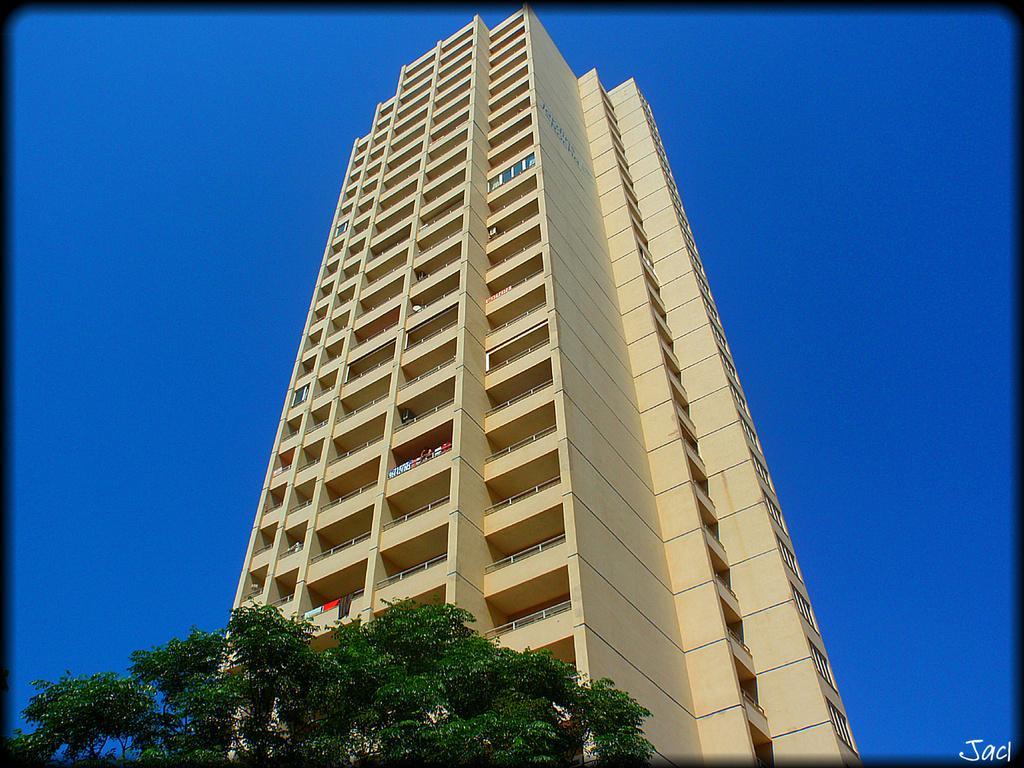How would you summarize this image in a sentence or two? In this image we can see branches, leaves, clothes, and a building. In the background there is sky. 